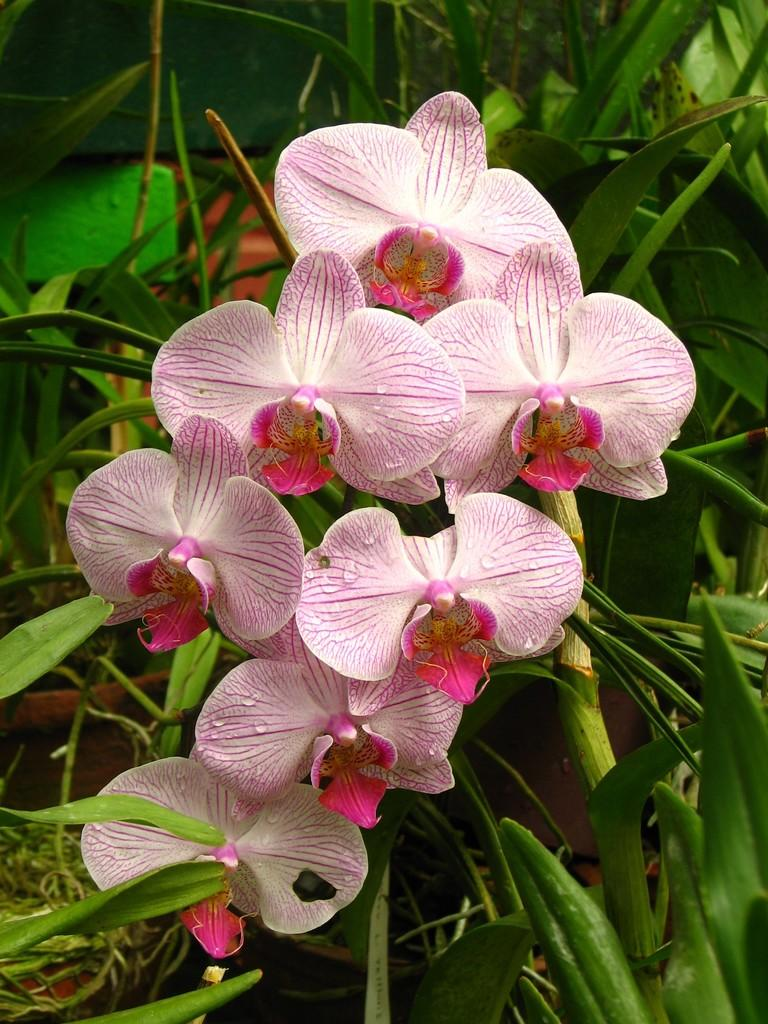What type of living organisms can be seen in the image? There are flowers and plants in the image. Can you describe the plants in the image? The plants in the image are not specified, but they are present alongside the flowers. What type of building can be seen in the image? There is no building present in the image; it features flowers and plants. How many slaves are visible in the image? There are no slaves present in the image; it features flowers and plants. 